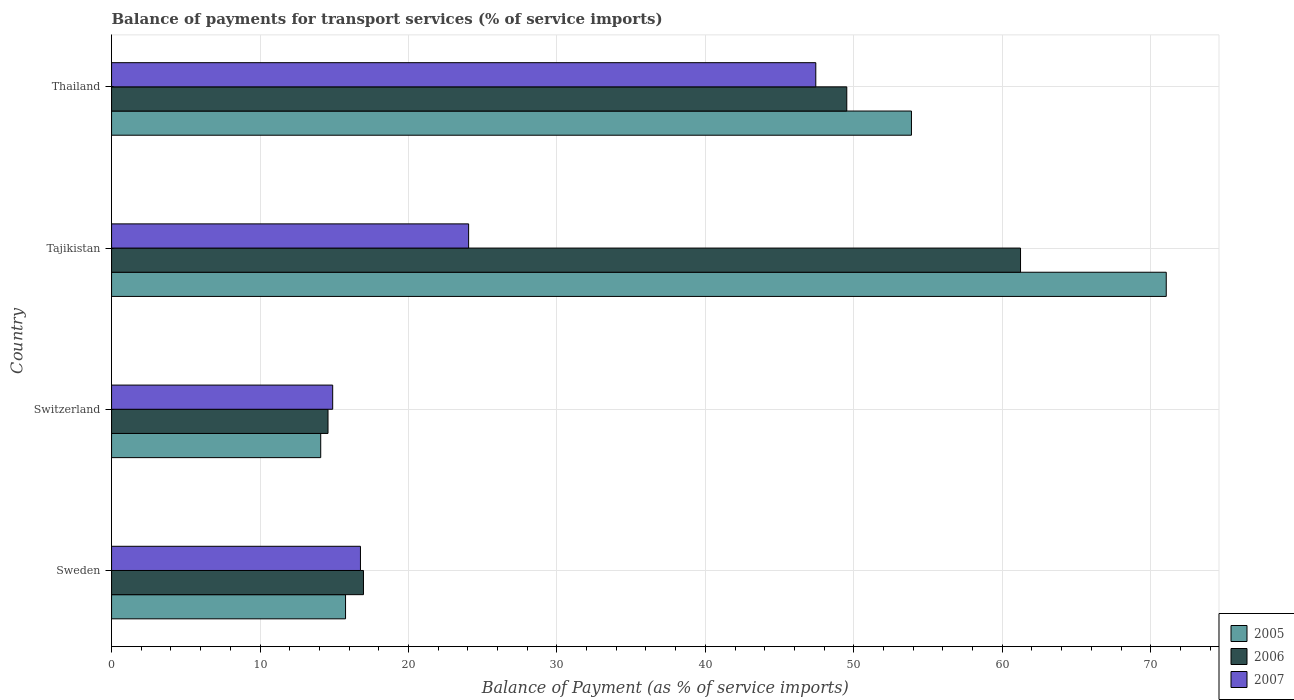Are the number of bars per tick equal to the number of legend labels?
Offer a very short reply. Yes. How many bars are there on the 1st tick from the top?
Keep it short and to the point. 3. How many bars are there on the 2nd tick from the bottom?
Offer a terse response. 3. What is the label of the 1st group of bars from the top?
Your answer should be compact. Thailand. What is the balance of payments for transport services in 2006 in Tajikistan?
Your answer should be very brief. 61.23. Across all countries, what is the maximum balance of payments for transport services in 2005?
Ensure brevity in your answer.  71.05. Across all countries, what is the minimum balance of payments for transport services in 2006?
Your answer should be very brief. 14.58. In which country was the balance of payments for transport services in 2005 maximum?
Provide a short and direct response. Tajikistan. In which country was the balance of payments for transport services in 2007 minimum?
Your answer should be compact. Switzerland. What is the total balance of payments for transport services in 2005 in the graph?
Make the answer very short. 154.79. What is the difference between the balance of payments for transport services in 2006 in Sweden and that in Switzerland?
Offer a terse response. 2.39. What is the difference between the balance of payments for transport services in 2006 in Tajikistan and the balance of payments for transport services in 2005 in Sweden?
Your response must be concise. 45.47. What is the average balance of payments for transport services in 2007 per country?
Offer a terse response. 25.79. What is the difference between the balance of payments for transport services in 2006 and balance of payments for transport services in 2005 in Switzerland?
Your answer should be very brief. 0.49. What is the ratio of the balance of payments for transport services in 2007 in Sweden to that in Thailand?
Ensure brevity in your answer.  0.35. Is the balance of payments for transport services in 2005 in Switzerland less than that in Tajikistan?
Provide a short and direct response. Yes. What is the difference between the highest and the second highest balance of payments for transport services in 2007?
Provide a short and direct response. 23.39. What is the difference between the highest and the lowest balance of payments for transport services in 2005?
Your answer should be very brief. 56.96. Is the sum of the balance of payments for transport services in 2005 in Tajikistan and Thailand greater than the maximum balance of payments for transport services in 2007 across all countries?
Your answer should be very brief. Yes. What does the 2nd bar from the bottom in Sweden represents?
Make the answer very short. 2006. Is it the case that in every country, the sum of the balance of payments for transport services in 2006 and balance of payments for transport services in 2007 is greater than the balance of payments for transport services in 2005?
Provide a short and direct response. Yes. How many bars are there?
Offer a very short reply. 12. What is the difference between two consecutive major ticks on the X-axis?
Ensure brevity in your answer.  10. Are the values on the major ticks of X-axis written in scientific E-notation?
Offer a terse response. No. How many legend labels are there?
Keep it short and to the point. 3. What is the title of the graph?
Give a very brief answer. Balance of payments for transport services (% of service imports). What is the label or title of the X-axis?
Provide a succinct answer. Balance of Payment (as % of service imports). What is the label or title of the Y-axis?
Your response must be concise. Country. What is the Balance of Payment (as % of service imports) of 2005 in Sweden?
Make the answer very short. 15.76. What is the Balance of Payment (as % of service imports) in 2006 in Sweden?
Offer a terse response. 16.97. What is the Balance of Payment (as % of service imports) of 2007 in Sweden?
Ensure brevity in your answer.  16.77. What is the Balance of Payment (as % of service imports) in 2005 in Switzerland?
Provide a succinct answer. 14.09. What is the Balance of Payment (as % of service imports) of 2006 in Switzerland?
Ensure brevity in your answer.  14.58. What is the Balance of Payment (as % of service imports) of 2007 in Switzerland?
Keep it short and to the point. 14.9. What is the Balance of Payment (as % of service imports) in 2005 in Tajikistan?
Offer a terse response. 71.05. What is the Balance of Payment (as % of service imports) of 2006 in Tajikistan?
Provide a short and direct response. 61.23. What is the Balance of Payment (as % of service imports) in 2007 in Tajikistan?
Your response must be concise. 24.05. What is the Balance of Payment (as % of service imports) of 2005 in Thailand?
Make the answer very short. 53.88. What is the Balance of Payment (as % of service imports) of 2006 in Thailand?
Offer a terse response. 49.53. What is the Balance of Payment (as % of service imports) in 2007 in Thailand?
Offer a very short reply. 47.44. Across all countries, what is the maximum Balance of Payment (as % of service imports) of 2005?
Offer a terse response. 71.05. Across all countries, what is the maximum Balance of Payment (as % of service imports) in 2006?
Keep it short and to the point. 61.23. Across all countries, what is the maximum Balance of Payment (as % of service imports) of 2007?
Ensure brevity in your answer.  47.44. Across all countries, what is the minimum Balance of Payment (as % of service imports) of 2005?
Make the answer very short. 14.09. Across all countries, what is the minimum Balance of Payment (as % of service imports) in 2006?
Your response must be concise. 14.58. Across all countries, what is the minimum Balance of Payment (as % of service imports) of 2007?
Make the answer very short. 14.9. What is the total Balance of Payment (as % of service imports) in 2005 in the graph?
Your answer should be very brief. 154.79. What is the total Balance of Payment (as % of service imports) of 2006 in the graph?
Your response must be concise. 142.31. What is the total Balance of Payment (as % of service imports) of 2007 in the graph?
Your response must be concise. 103.16. What is the difference between the Balance of Payment (as % of service imports) of 2005 in Sweden and that in Switzerland?
Provide a short and direct response. 1.67. What is the difference between the Balance of Payment (as % of service imports) in 2006 in Sweden and that in Switzerland?
Offer a terse response. 2.39. What is the difference between the Balance of Payment (as % of service imports) of 2007 in Sweden and that in Switzerland?
Provide a succinct answer. 1.87. What is the difference between the Balance of Payment (as % of service imports) of 2005 in Sweden and that in Tajikistan?
Provide a short and direct response. -55.29. What is the difference between the Balance of Payment (as % of service imports) in 2006 in Sweden and that in Tajikistan?
Provide a short and direct response. -44.26. What is the difference between the Balance of Payment (as % of service imports) in 2007 in Sweden and that in Tajikistan?
Your answer should be very brief. -7.29. What is the difference between the Balance of Payment (as % of service imports) in 2005 in Sweden and that in Thailand?
Offer a very short reply. -38.12. What is the difference between the Balance of Payment (as % of service imports) in 2006 in Sweden and that in Thailand?
Your response must be concise. -32.56. What is the difference between the Balance of Payment (as % of service imports) of 2007 in Sweden and that in Thailand?
Provide a succinct answer. -30.67. What is the difference between the Balance of Payment (as % of service imports) in 2005 in Switzerland and that in Tajikistan?
Ensure brevity in your answer.  -56.96. What is the difference between the Balance of Payment (as % of service imports) of 2006 in Switzerland and that in Tajikistan?
Offer a very short reply. -46.65. What is the difference between the Balance of Payment (as % of service imports) in 2007 in Switzerland and that in Tajikistan?
Make the answer very short. -9.16. What is the difference between the Balance of Payment (as % of service imports) in 2005 in Switzerland and that in Thailand?
Keep it short and to the point. -39.79. What is the difference between the Balance of Payment (as % of service imports) of 2006 in Switzerland and that in Thailand?
Keep it short and to the point. -34.95. What is the difference between the Balance of Payment (as % of service imports) in 2007 in Switzerland and that in Thailand?
Provide a short and direct response. -32.54. What is the difference between the Balance of Payment (as % of service imports) of 2005 in Tajikistan and that in Thailand?
Offer a terse response. 17.16. What is the difference between the Balance of Payment (as % of service imports) in 2006 in Tajikistan and that in Thailand?
Your answer should be very brief. 11.7. What is the difference between the Balance of Payment (as % of service imports) in 2007 in Tajikistan and that in Thailand?
Offer a very short reply. -23.39. What is the difference between the Balance of Payment (as % of service imports) in 2005 in Sweden and the Balance of Payment (as % of service imports) in 2006 in Switzerland?
Your response must be concise. 1.18. What is the difference between the Balance of Payment (as % of service imports) in 2005 in Sweden and the Balance of Payment (as % of service imports) in 2007 in Switzerland?
Offer a very short reply. 0.87. What is the difference between the Balance of Payment (as % of service imports) of 2006 in Sweden and the Balance of Payment (as % of service imports) of 2007 in Switzerland?
Your answer should be very brief. 2.07. What is the difference between the Balance of Payment (as % of service imports) of 2005 in Sweden and the Balance of Payment (as % of service imports) of 2006 in Tajikistan?
Provide a short and direct response. -45.47. What is the difference between the Balance of Payment (as % of service imports) of 2005 in Sweden and the Balance of Payment (as % of service imports) of 2007 in Tajikistan?
Offer a terse response. -8.29. What is the difference between the Balance of Payment (as % of service imports) in 2006 in Sweden and the Balance of Payment (as % of service imports) in 2007 in Tajikistan?
Provide a short and direct response. -7.08. What is the difference between the Balance of Payment (as % of service imports) in 2005 in Sweden and the Balance of Payment (as % of service imports) in 2006 in Thailand?
Offer a terse response. -33.77. What is the difference between the Balance of Payment (as % of service imports) in 2005 in Sweden and the Balance of Payment (as % of service imports) in 2007 in Thailand?
Make the answer very short. -31.68. What is the difference between the Balance of Payment (as % of service imports) of 2006 in Sweden and the Balance of Payment (as % of service imports) of 2007 in Thailand?
Offer a terse response. -30.47. What is the difference between the Balance of Payment (as % of service imports) in 2005 in Switzerland and the Balance of Payment (as % of service imports) in 2006 in Tajikistan?
Give a very brief answer. -47.14. What is the difference between the Balance of Payment (as % of service imports) in 2005 in Switzerland and the Balance of Payment (as % of service imports) in 2007 in Tajikistan?
Your response must be concise. -9.96. What is the difference between the Balance of Payment (as % of service imports) of 2006 in Switzerland and the Balance of Payment (as % of service imports) of 2007 in Tajikistan?
Ensure brevity in your answer.  -9.47. What is the difference between the Balance of Payment (as % of service imports) of 2005 in Switzerland and the Balance of Payment (as % of service imports) of 2006 in Thailand?
Your response must be concise. -35.44. What is the difference between the Balance of Payment (as % of service imports) of 2005 in Switzerland and the Balance of Payment (as % of service imports) of 2007 in Thailand?
Offer a terse response. -33.35. What is the difference between the Balance of Payment (as % of service imports) of 2006 in Switzerland and the Balance of Payment (as % of service imports) of 2007 in Thailand?
Provide a short and direct response. -32.86. What is the difference between the Balance of Payment (as % of service imports) of 2005 in Tajikistan and the Balance of Payment (as % of service imports) of 2006 in Thailand?
Provide a succinct answer. 21.52. What is the difference between the Balance of Payment (as % of service imports) in 2005 in Tajikistan and the Balance of Payment (as % of service imports) in 2007 in Thailand?
Provide a short and direct response. 23.61. What is the difference between the Balance of Payment (as % of service imports) in 2006 in Tajikistan and the Balance of Payment (as % of service imports) in 2007 in Thailand?
Provide a short and direct response. 13.79. What is the average Balance of Payment (as % of service imports) of 2005 per country?
Ensure brevity in your answer.  38.7. What is the average Balance of Payment (as % of service imports) of 2006 per country?
Offer a terse response. 35.58. What is the average Balance of Payment (as % of service imports) in 2007 per country?
Make the answer very short. 25.79. What is the difference between the Balance of Payment (as % of service imports) of 2005 and Balance of Payment (as % of service imports) of 2006 in Sweden?
Offer a very short reply. -1.21. What is the difference between the Balance of Payment (as % of service imports) of 2005 and Balance of Payment (as % of service imports) of 2007 in Sweden?
Offer a terse response. -1. What is the difference between the Balance of Payment (as % of service imports) in 2006 and Balance of Payment (as % of service imports) in 2007 in Sweden?
Provide a short and direct response. 0.2. What is the difference between the Balance of Payment (as % of service imports) of 2005 and Balance of Payment (as % of service imports) of 2006 in Switzerland?
Provide a succinct answer. -0.49. What is the difference between the Balance of Payment (as % of service imports) in 2005 and Balance of Payment (as % of service imports) in 2007 in Switzerland?
Give a very brief answer. -0.81. What is the difference between the Balance of Payment (as % of service imports) in 2006 and Balance of Payment (as % of service imports) in 2007 in Switzerland?
Offer a very short reply. -0.32. What is the difference between the Balance of Payment (as % of service imports) in 2005 and Balance of Payment (as % of service imports) in 2006 in Tajikistan?
Offer a very short reply. 9.82. What is the difference between the Balance of Payment (as % of service imports) in 2005 and Balance of Payment (as % of service imports) in 2007 in Tajikistan?
Offer a terse response. 47. What is the difference between the Balance of Payment (as % of service imports) of 2006 and Balance of Payment (as % of service imports) of 2007 in Tajikistan?
Keep it short and to the point. 37.18. What is the difference between the Balance of Payment (as % of service imports) in 2005 and Balance of Payment (as % of service imports) in 2006 in Thailand?
Provide a succinct answer. 4.36. What is the difference between the Balance of Payment (as % of service imports) of 2005 and Balance of Payment (as % of service imports) of 2007 in Thailand?
Ensure brevity in your answer.  6.44. What is the difference between the Balance of Payment (as % of service imports) in 2006 and Balance of Payment (as % of service imports) in 2007 in Thailand?
Provide a succinct answer. 2.09. What is the ratio of the Balance of Payment (as % of service imports) of 2005 in Sweden to that in Switzerland?
Ensure brevity in your answer.  1.12. What is the ratio of the Balance of Payment (as % of service imports) of 2006 in Sweden to that in Switzerland?
Offer a terse response. 1.16. What is the ratio of the Balance of Payment (as % of service imports) of 2007 in Sweden to that in Switzerland?
Ensure brevity in your answer.  1.13. What is the ratio of the Balance of Payment (as % of service imports) of 2005 in Sweden to that in Tajikistan?
Your answer should be very brief. 0.22. What is the ratio of the Balance of Payment (as % of service imports) in 2006 in Sweden to that in Tajikistan?
Keep it short and to the point. 0.28. What is the ratio of the Balance of Payment (as % of service imports) of 2007 in Sweden to that in Tajikistan?
Your response must be concise. 0.7. What is the ratio of the Balance of Payment (as % of service imports) of 2005 in Sweden to that in Thailand?
Offer a very short reply. 0.29. What is the ratio of the Balance of Payment (as % of service imports) of 2006 in Sweden to that in Thailand?
Make the answer very short. 0.34. What is the ratio of the Balance of Payment (as % of service imports) in 2007 in Sweden to that in Thailand?
Your answer should be very brief. 0.35. What is the ratio of the Balance of Payment (as % of service imports) of 2005 in Switzerland to that in Tajikistan?
Make the answer very short. 0.2. What is the ratio of the Balance of Payment (as % of service imports) in 2006 in Switzerland to that in Tajikistan?
Your response must be concise. 0.24. What is the ratio of the Balance of Payment (as % of service imports) of 2007 in Switzerland to that in Tajikistan?
Give a very brief answer. 0.62. What is the ratio of the Balance of Payment (as % of service imports) in 2005 in Switzerland to that in Thailand?
Offer a terse response. 0.26. What is the ratio of the Balance of Payment (as % of service imports) in 2006 in Switzerland to that in Thailand?
Your response must be concise. 0.29. What is the ratio of the Balance of Payment (as % of service imports) in 2007 in Switzerland to that in Thailand?
Offer a very short reply. 0.31. What is the ratio of the Balance of Payment (as % of service imports) of 2005 in Tajikistan to that in Thailand?
Provide a short and direct response. 1.32. What is the ratio of the Balance of Payment (as % of service imports) of 2006 in Tajikistan to that in Thailand?
Ensure brevity in your answer.  1.24. What is the ratio of the Balance of Payment (as % of service imports) of 2007 in Tajikistan to that in Thailand?
Your answer should be compact. 0.51. What is the difference between the highest and the second highest Balance of Payment (as % of service imports) of 2005?
Provide a short and direct response. 17.16. What is the difference between the highest and the second highest Balance of Payment (as % of service imports) of 2006?
Give a very brief answer. 11.7. What is the difference between the highest and the second highest Balance of Payment (as % of service imports) in 2007?
Offer a very short reply. 23.39. What is the difference between the highest and the lowest Balance of Payment (as % of service imports) in 2005?
Provide a short and direct response. 56.96. What is the difference between the highest and the lowest Balance of Payment (as % of service imports) in 2006?
Keep it short and to the point. 46.65. What is the difference between the highest and the lowest Balance of Payment (as % of service imports) in 2007?
Offer a terse response. 32.54. 